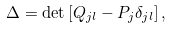<formula> <loc_0><loc_0><loc_500><loc_500>\Delta = \det \left [ Q _ { j l } - P _ { j } \delta _ { j l } \right ] ,</formula> 